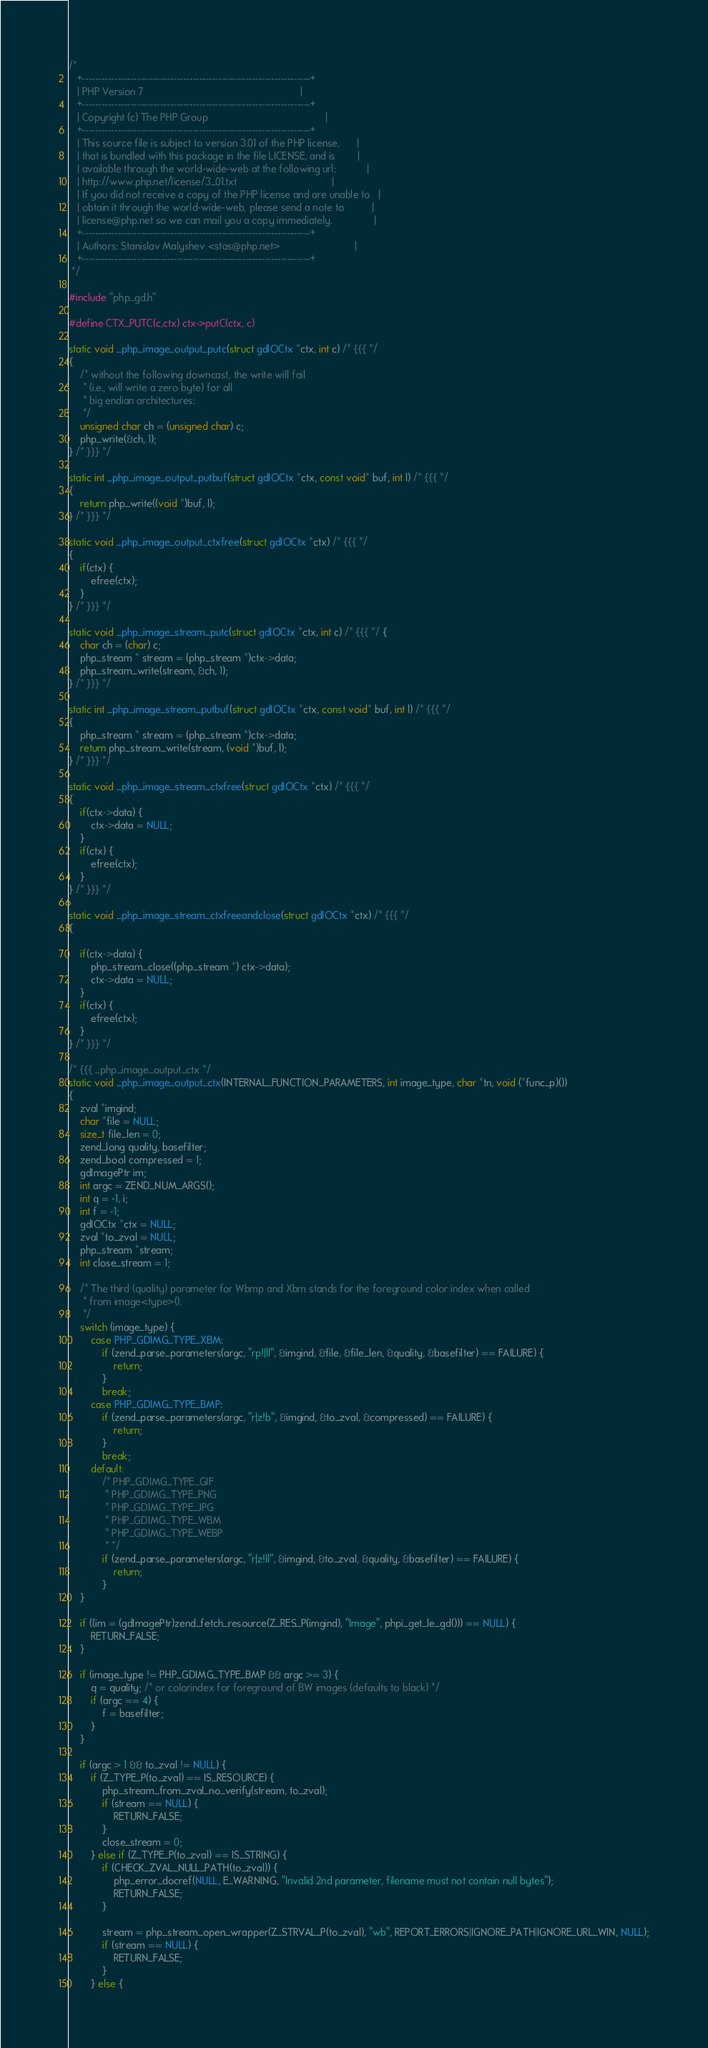Convert code to text. <code><loc_0><loc_0><loc_500><loc_500><_C_>/*
   +----------------------------------------------------------------------+
   | PHP Version 7                                                        |
   +----------------------------------------------------------------------+
   | Copyright (c) The PHP Group                                          |
   +----------------------------------------------------------------------+
   | This source file is subject to version 3.01 of the PHP license,      |
   | that is bundled with this package in the file LICENSE, and is        |
   | available through the world-wide-web at the following url:           |
   | http://www.php.net/license/3_01.txt                                  |
   | If you did not receive a copy of the PHP license and are unable to   |
   | obtain it through the world-wide-web, please send a note to          |
   | license@php.net so we can mail you a copy immediately.               |
   +----------------------------------------------------------------------+
   | Authors: Stanislav Malyshev <stas@php.net>                           |
   +----------------------------------------------------------------------+
 */

#include "php_gd.h"

#define CTX_PUTC(c,ctx) ctx->putC(ctx, c)

static void _php_image_output_putc(struct gdIOCtx *ctx, int c) /* {{{ */
{
	/* without the following downcast, the write will fail
	 * (i.e., will write a zero byte) for all
	 * big endian architectures:
	 */
	unsigned char ch = (unsigned char) c;
	php_write(&ch, 1);
} /* }}} */

static int _php_image_output_putbuf(struct gdIOCtx *ctx, const void* buf, int l) /* {{{ */
{
	return php_write((void *)buf, l);
} /* }}} */

static void _php_image_output_ctxfree(struct gdIOCtx *ctx) /* {{{ */
{
	if(ctx) {
		efree(ctx);
	}
} /* }}} */

static void _php_image_stream_putc(struct gdIOCtx *ctx, int c) /* {{{ */ {
	char ch = (char) c;
	php_stream * stream = (php_stream *)ctx->data;
	php_stream_write(stream, &ch, 1);
} /* }}} */

static int _php_image_stream_putbuf(struct gdIOCtx *ctx, const void* buf, int l) /* {{{ */
{
	php_stream * stream = (php_stream *)ctx->data;
	return php_stream_write(stream, (void *)buf, l);
} /* }}} */

static void _php_image_stream_ctxfree(struct gdIOCtx *ctx) /* {{{ */
{
	if(ctx->data) {
		ctx->data = NULL;
	}
	if(ctx) {
		efree(ctx);
	}
} /* }}} */

static void _php_image_stream_ctxfreeandclose(struct gdIOCtx *ctx) /* {{{ */
{

	if(ctx->data) {
		php_stream_close((php_stream *) ctx->data);
		ctx->data = NULL;
	}
	if(ctx) {
		efree(ctx);
	}
} /* }}} */

/* {{{ _php_image_output_ctx */
static void _php_image_output_ctx(INTERNAL_FUNCTION_PARAMETERS, int image_type, char *tn, void (*func_p)())
{
	zval *imgind;
	char *file = NULL;
	size_t file_len = 0;
	zend_long quality, basefilter;
	zend_bool compressed = 1;
	gdImagePtr im;
	int argc = ZEND_NUM_ARGS();
	int q = -1, i;
	int f = -1;
	gdIOCtx *ctx = NULL;
	zval *to_zval = NULL;
	php_stream *stream;
	int close_stream = 1;

	/* The third (quality) parameter for Wbmp and Xbm stands for the foreground color index when called
	 * from image<type>().
	 */
	switch (image_type) {
		case PHP_GDIMG_TYPE_XBM:
			if (zend_parse_parameters(argc, "rp!|ll", &imgind, &file, &file_len, &quality, &basefilter) == FAILURE) {
				return;
			}
			break;
		case PHP_GDIMG_TYPE_BMP:
			if (zend_parse_parameters(argc, "r|z!b", &imgind, &to_zval, &compressed) == FAILURE) {
				return;
			}
			break;
		default:
			/* PHP_GDIMG_TYPE_GIF
			 * PHP_GDIMG_TYPE_PNG
			 * PHP_GDIMG_TYPE_JPG
			 * PHP_GDIMG_TYPE_WBM
			 * PHP_GDIMG_TYPE_WEBP
			 * */
			if (zend_parse_parameters(argc, "r|z!ll", &imgind, &to_zval, &quality, &basefilter) == FAILURE) {
				return;
			}
	}

	if ((im = (gdImagePtr)zend_fetch_resource(Z_RES_P(imgind), "Image", phpi_get_le_gd())) == NULL) {
		RETURN_FALSE;
	}

	if (image_type != PHP_GDIMG_TYPE_BMP && argc >= 3) {
		q = quality; /* or colorindex for foreground of BW images (defaults to black) */
		if (argc == 4) {
			f = basefilter;
		}
	}

	if (argc > 1 && to_zval != NULL) {
		if (Z_TYPE_P(to_zval) == IS_RESOURCE) {
			php_stream_from_zval_no_verify(stream, to_zval);
			if (stream == NULL) {
				RETURN_FALSE;
			}
			close_stream = 0;
		} else if (Z_TYPE_P(to_zval) == IS_STRING) {
			if (CHECK_ZVAL_NULL_PATH(to_zval)) {
				php_error_docref(NULL, E_WARNING, "Invalid 2nd parameter, filename must not contain null bytes");
				RETURN_FALSE;
			}

			stream = php_stream_open_wrapper(Z_STRVAL_P(to_zval), "wb", REPORT_ERRORS|IGNORE_PATH|IGNORE_URL_WIN, NULL);
			if (stream == NULL) {
				RETURN_FALSE;
			}
		} else {</code> 